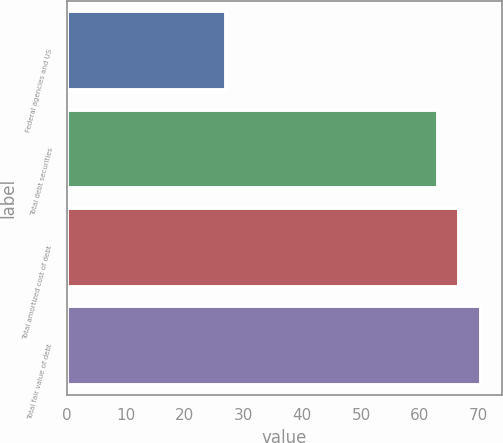<chart> <loc_0><loc_0><loc_500><loc_500><bar_chart><fcel>Federal agencies and US<fcel>Total debt securities<fcel>Total amortized cost of debt<fcel>Total fair value of debt<nl><fcel>27<fcel>63<fcel>66.7<fcel>70.4<nl></chart> 